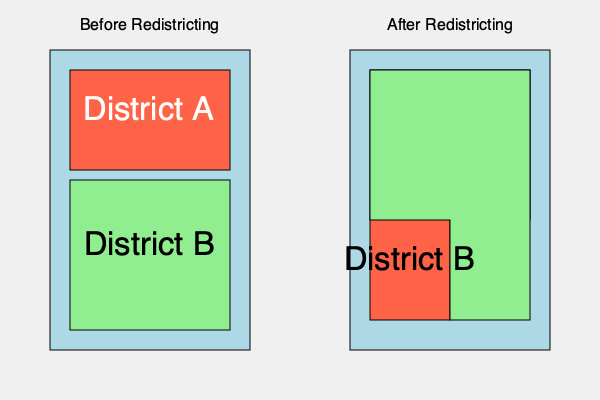Analyzing the redistricting map of a region in Texas, what potential impact could this change have on the election results for District A, and how might this relate to the concept of gerrymandering? To analyze the impact of redistricting on election results in Texas, we need to consider several factors:

1. District shape change: The map shows a significant alteration in the shape of District A after redistricting.

2. Area distribution: 
   - Before: District A was a compact rectangle occupying the upper third of the region.
   - After: District A now has an irregular shape, encompassing most of the original area plus a significant portion of what was previously District B.

3. Population distribution:
   - Assuming population density is relatively uniform, the new District A now includes a larger population than before.
   - This change likely incorporates more voters from the former District B into District A.

4. Potential political implications:
   - If District B previously had a different political leaning than District A, this redistricting could significantly alter the voter composition of District A.
   - For example, if District A was predominantly one party and District B another, the new District A might now have a more mixed voter base.

5. Gerrymandering connection:
   - Gerrymandering is the practice of manipulating district boundaries for political advantage.
   - The irregular shape of the new District A, which appears to specifically incorporate parts of the old District B, could be indicative of gerrymandering.
   - This practice can be used to either concentrate opposition voters into fewer districts or dilute their voting power across multiple districts.

6. Potential outcomes:
   - If this redistricting was done to favor the incumbent party in District A, it might result in a more secure seat for that party.
   - Conversely, if it was done to challenge the incumbent, it could lead to a more competitive race or a power shift.

7. Voter engagement:
   - Redistricting can affect voter turnout and engagement, especially if voters find themselves in a new district with unfamiliar candidates or perceived changed odds of their vote making a difference.

In conclusion, this redistricting could significantly impact election results in District A by altering its voter composition, potentially favoring one political party over another, and possibly representing a form of gerrymandering depending on the intent behind the boundary changes.
Answer: Potential for significant shift in District A's political balance; possible gerrymandering to favor a particular party. 